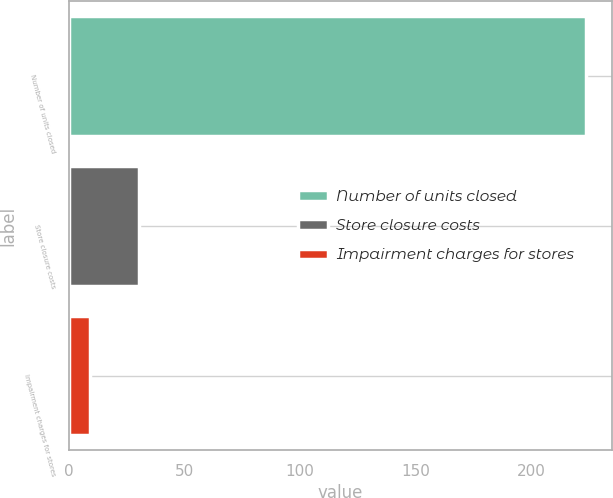<chart> <loc_0><loc_0><loc_500><loc_500><bar_chart><fcel>Number of units closed<fcel>Store closure costs<fcel>Impairment charges for stores<nl><fcel>224<fcel>30.5<fcel>9<nl></chart> 